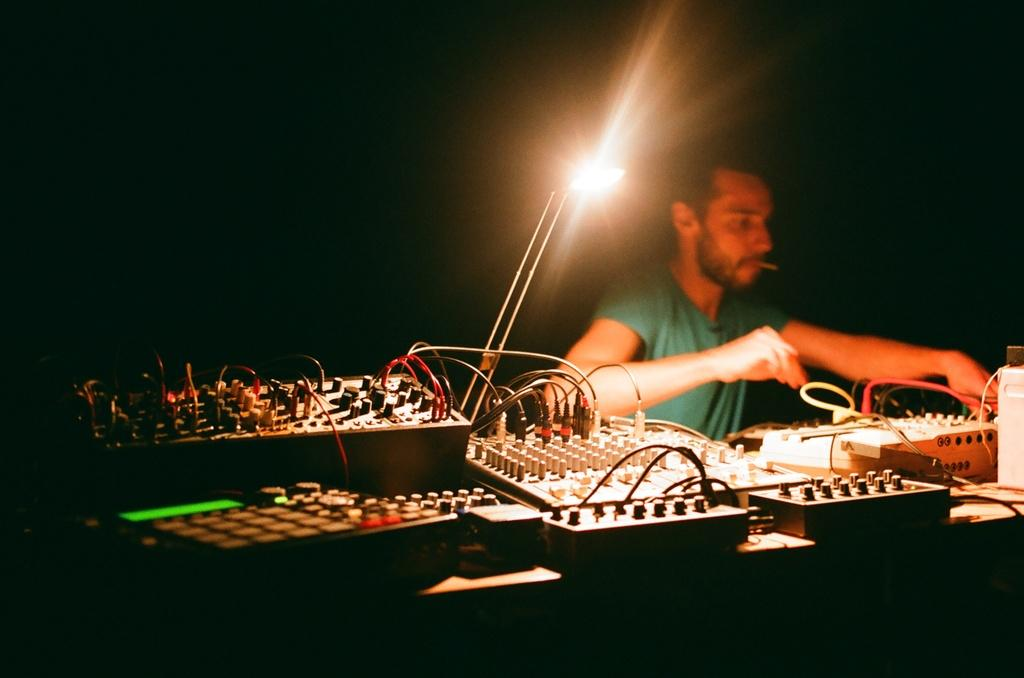Who is present in the image? There is a man in the image. What is in front of the man? There are machines and cables in front of the man. Can you describe the lighting in the image? There is light visible in the image. What is the color of the background in the image? The background of the image is dark. What type of celery is being used to fix the machines in the image? There is no celery present in the image, and it is not being used to fix any machines. 